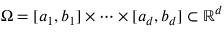<formula> <loc_0><loc_0><loc_500><loc_500>\Omega = [ a _ { 1 } , b _ { 1 } ] \times \cdots \times [ a _ { d } , b _ { d } ] \subset \mathbb { R } ^ { d }</formula> 